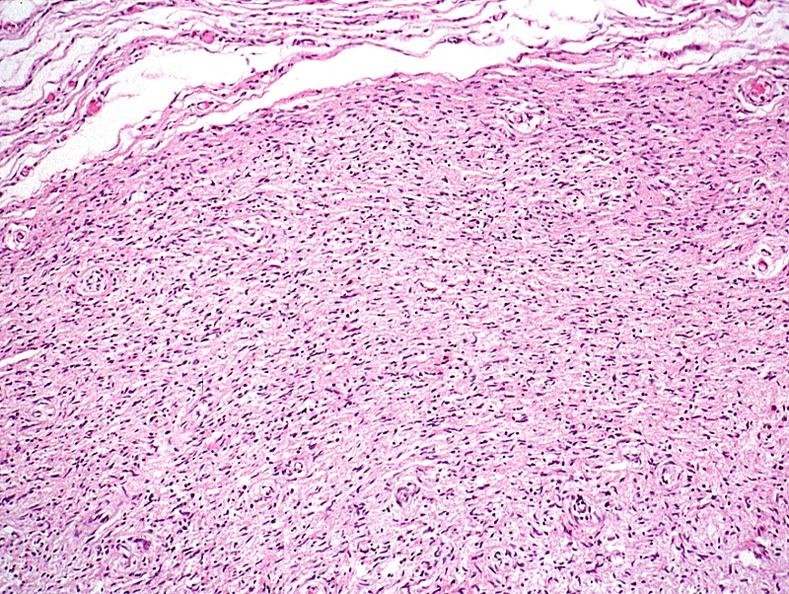does this image show skin, neurofibromatosis?
Answer the question using a single word or phrase. Yes 